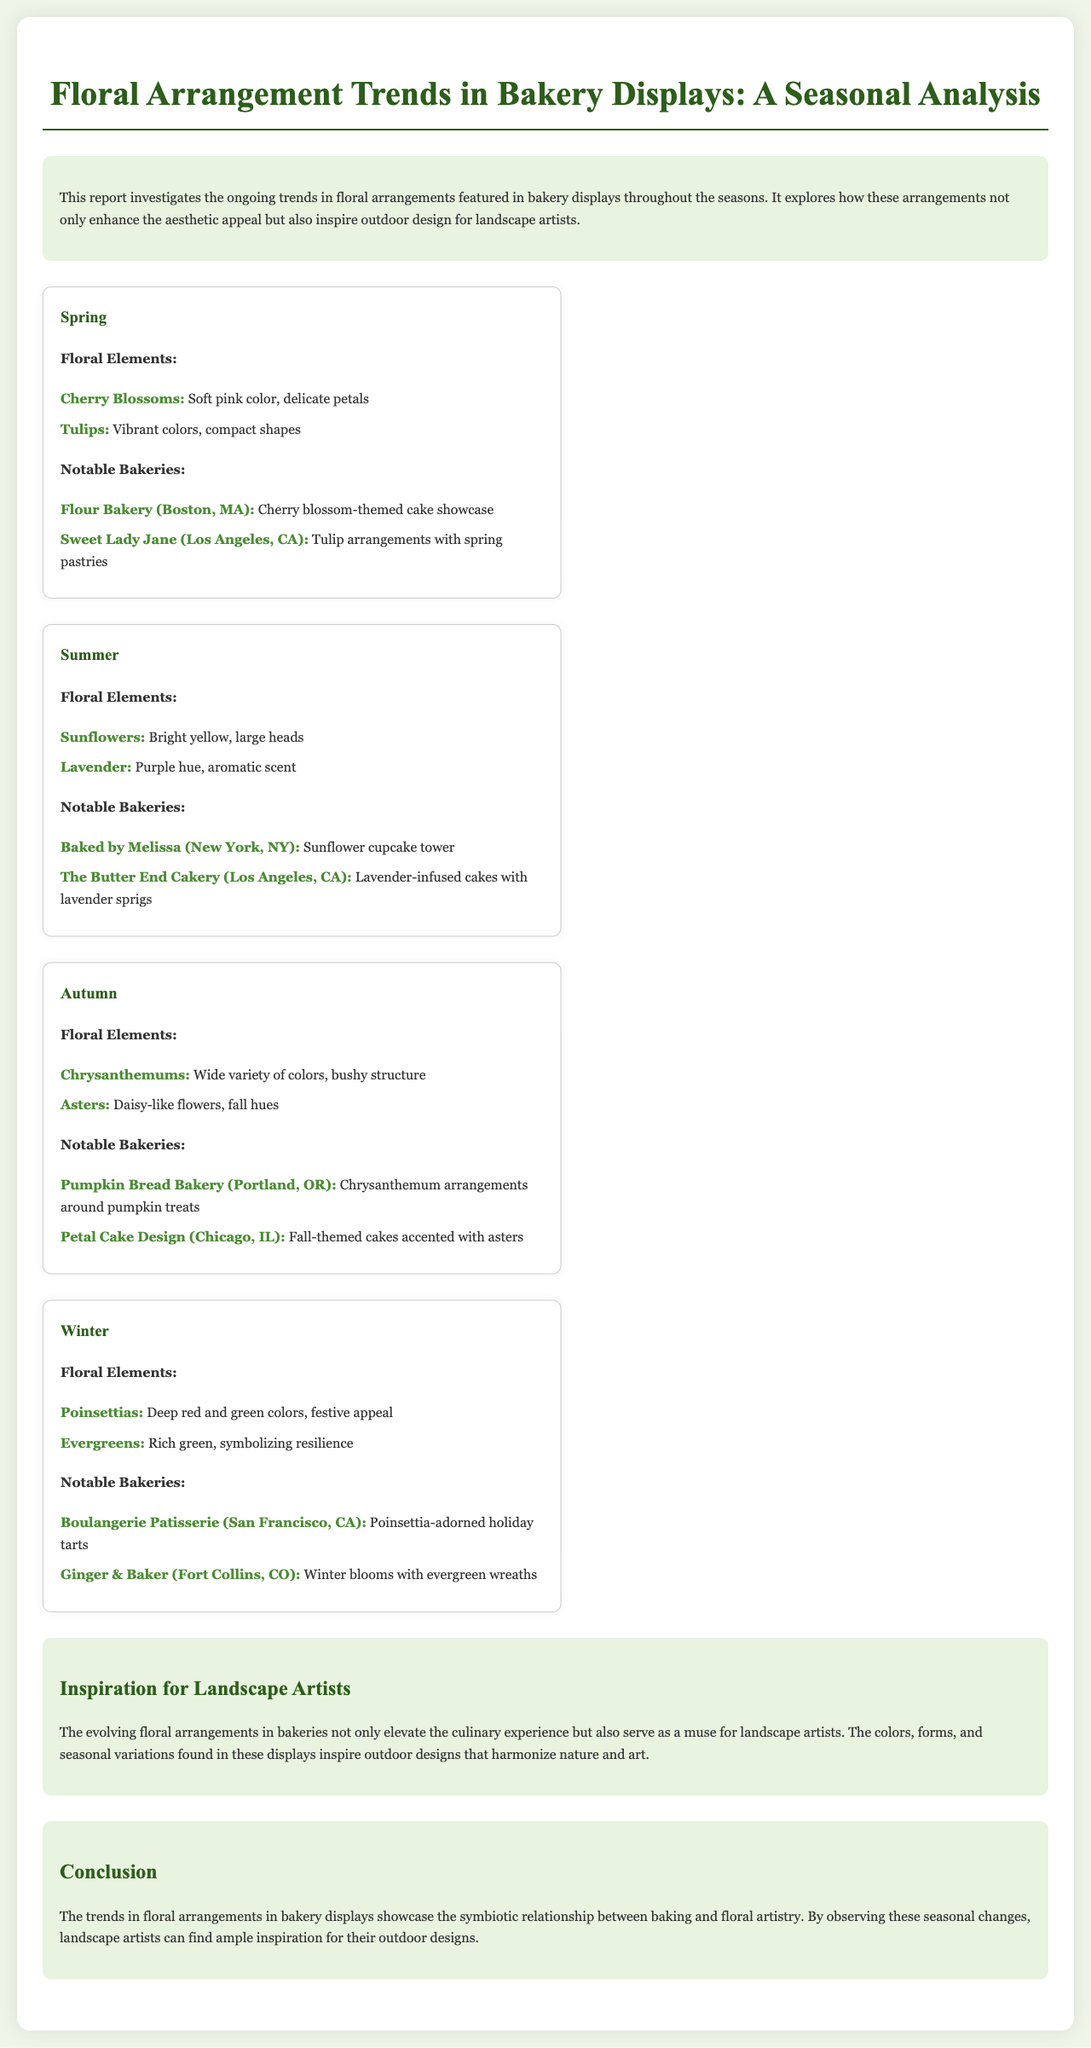what floral element is highlighted in spring? The report mentions cherry blossoms and tulips as floral elements highlighted in spring.
Answer: Cherry Blossoms, Tulips which bakery featured cherry blossom-themed cake? Flour Bakery in Boston is noted for its cherry blossom-themed cake showcase.
Answer: Flour Bakery (Boston, MA) what color are sunflowers? The report describes sunflowers as bright yellow, indicating their color.
Answer: Bright yellow which season features chrysanthemums? The document indicates that chrysanthemums are a floral element featured in autumn.
Answer: Autumn what floral arrangement inspires landscape artists according to the report? The report states that the evolving floral arrangements in bakeries serve as a muse for landscape artists.
Answer: Floral arrangements how many notable bakeries are mentioned for summer? There are two notable bakeries mentioned for summer in the document.
Answer: Two what is the main floral element in winter? The report identifies poinsettias as the main floral element in winter.
Answer: Poinsettias which city is associated with The Butter End Cakery? The report specifies that The Butter End Cakery is located in Los Angeles, CA.
Answer: Los Angeles, CA what is the conclusion about floral arrangements in bakery displays? The conclusion highlights the symbiotic relationship between baking and floral artistry.
Answer: Symbiotic relationship 